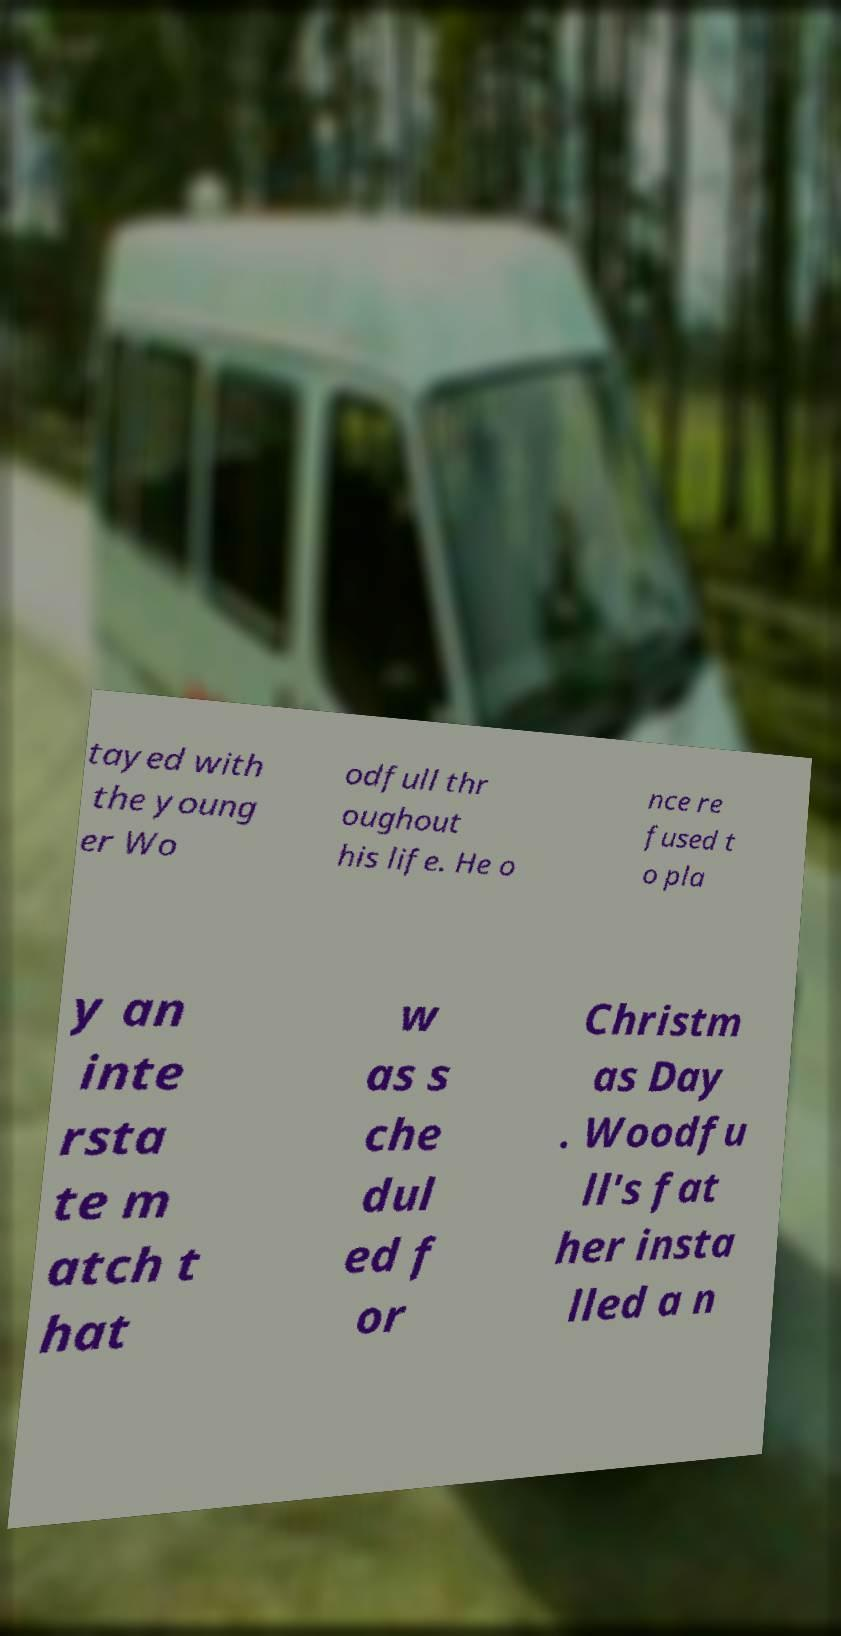For documentation purposes, I need the text within this image transcribed. Could you provide that? tayed with the young er Wo odfull thr oughout his life. He o nce re fused t o pla y an inte rsta te m atch t hat w as s che dul ed f or Christm as Day . Woodfu ll's fat her insta lled a n 